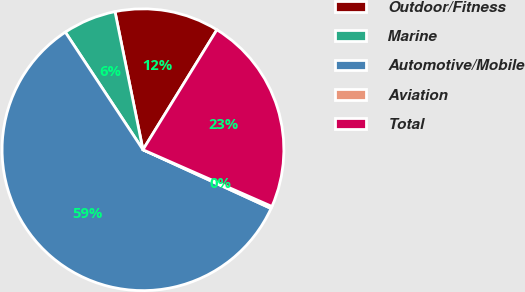Convert chart to OTSL. <chart><loc_0><loc_0><loc_500><loc_500><pie_chart><fcel>Outdoor/Fitness<fcel>Marine<fcel>Automotive/Mobile<fcel>Aviation<fcel>Total<nl><fcel>11.97%<fcel>6.11%<fcel>58.87%<fcel>0.25%<fcel>22.81%<nl></chart> 